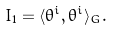Convert formula to latex. <formula><loc_0><loc_0><loc_500><loc_500>I _ { 1 } = \langle \theta ^ { i } , \theta ^ { i } \rangle _ { G } .</formula> 